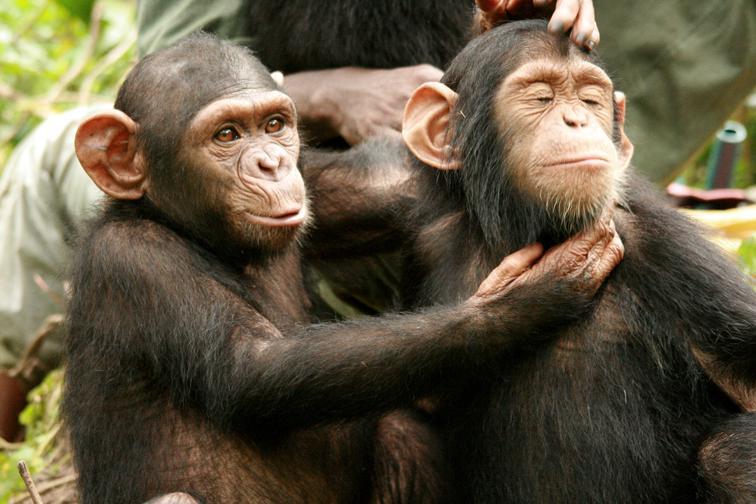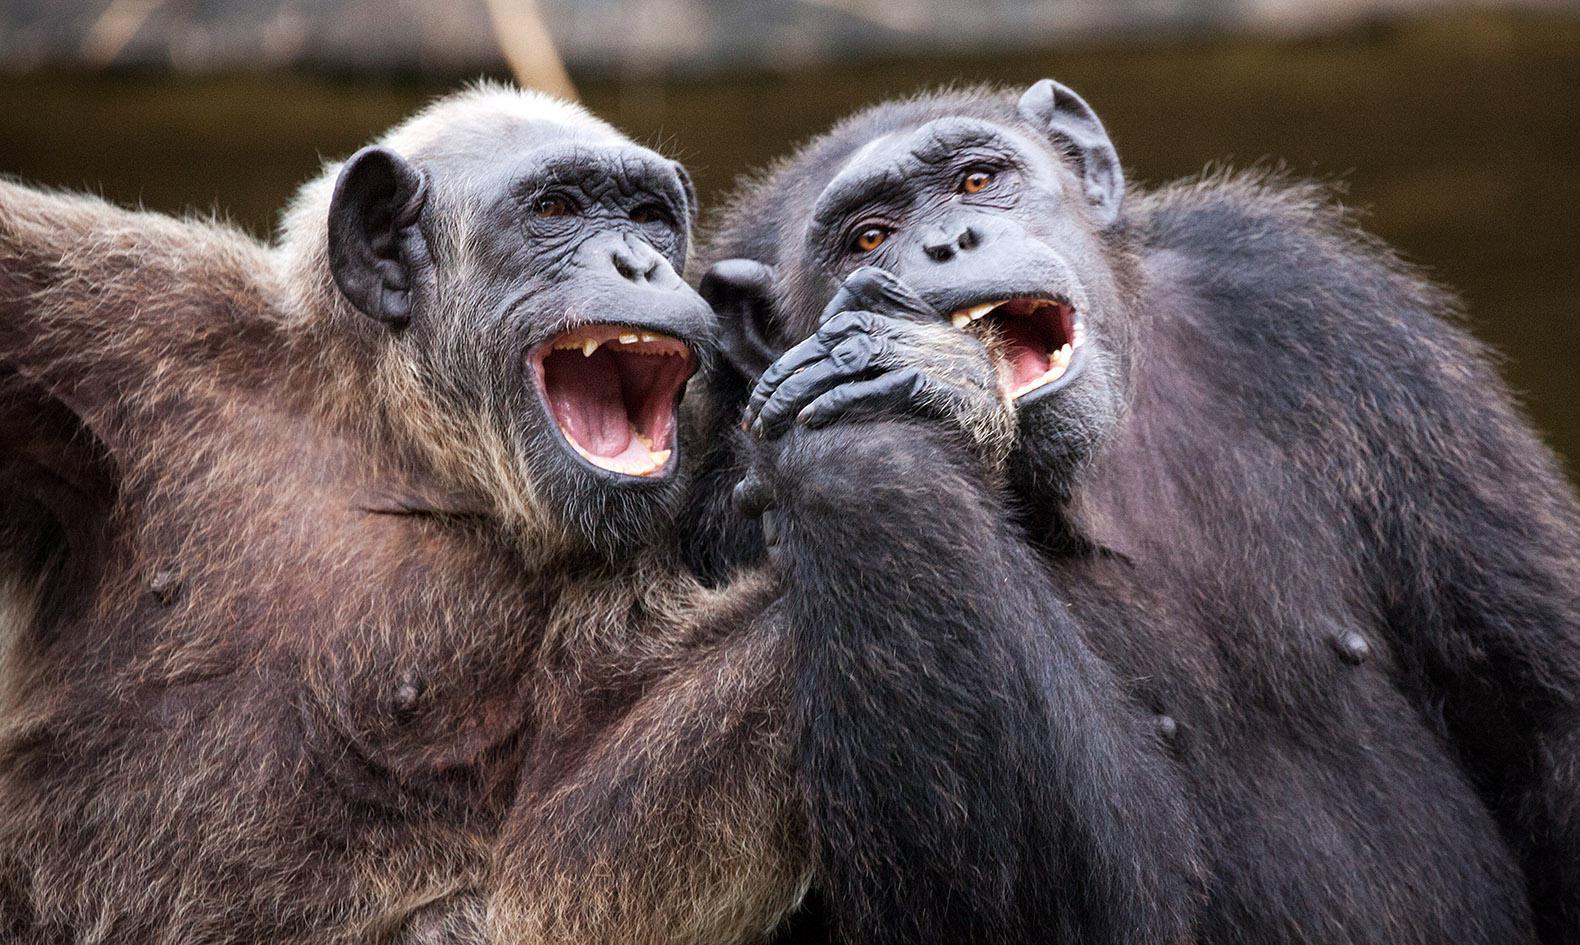The first image is the image on the left, the second image is the image on the right. Evaluate the accuracy of this statement regarding the images: "There is at least one money on the right that is showing its teeth". Is it true? Answer yes or no. Yes. The first image is the image on the left, the second image is the image on the right. For the images shown, is this caption "Each image shows two chimps posed side-by-side, but no chimp has a hand visibly grabbing the other chimp or a wide-open mouth." true? Answer yes or no. No. 